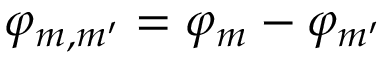<formula> <loc_0><loc_0><loc_500><loc_500>\varphi _ { m , m ^ { \prime } } = \varphi _ { m } - \varphi _ { m ^ { \prime } }</formula> 